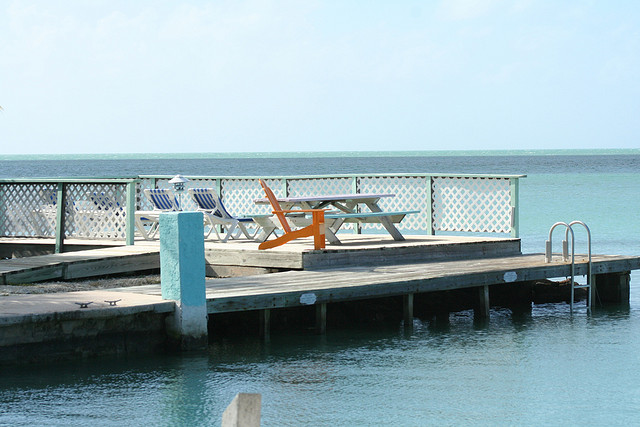<image>How many people can sit here? The number of people that can sit here is ambiguous, it ranges from '0' to '13'. How many people can sit here? I don't know how many people can sit here. 